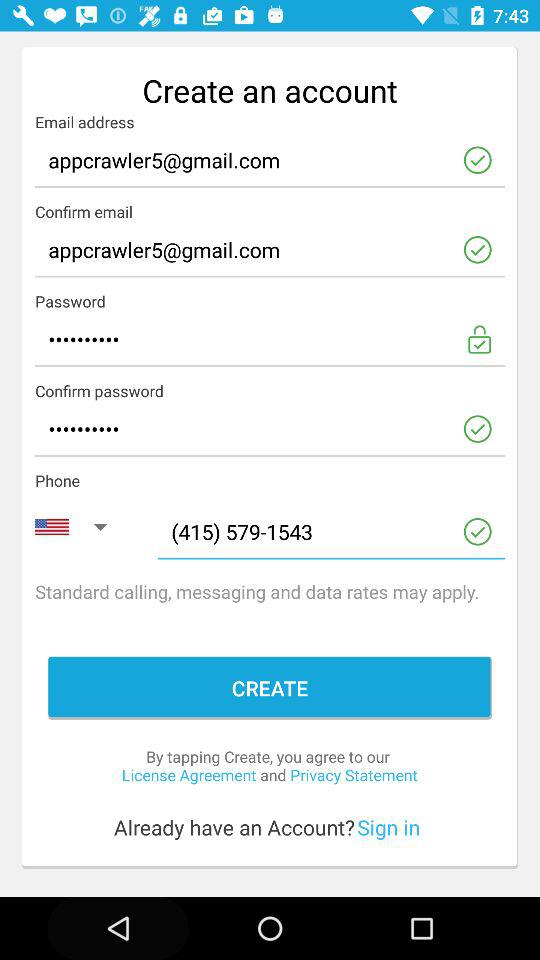What is the given phone number? The given phone number is (415) 579-1543. 